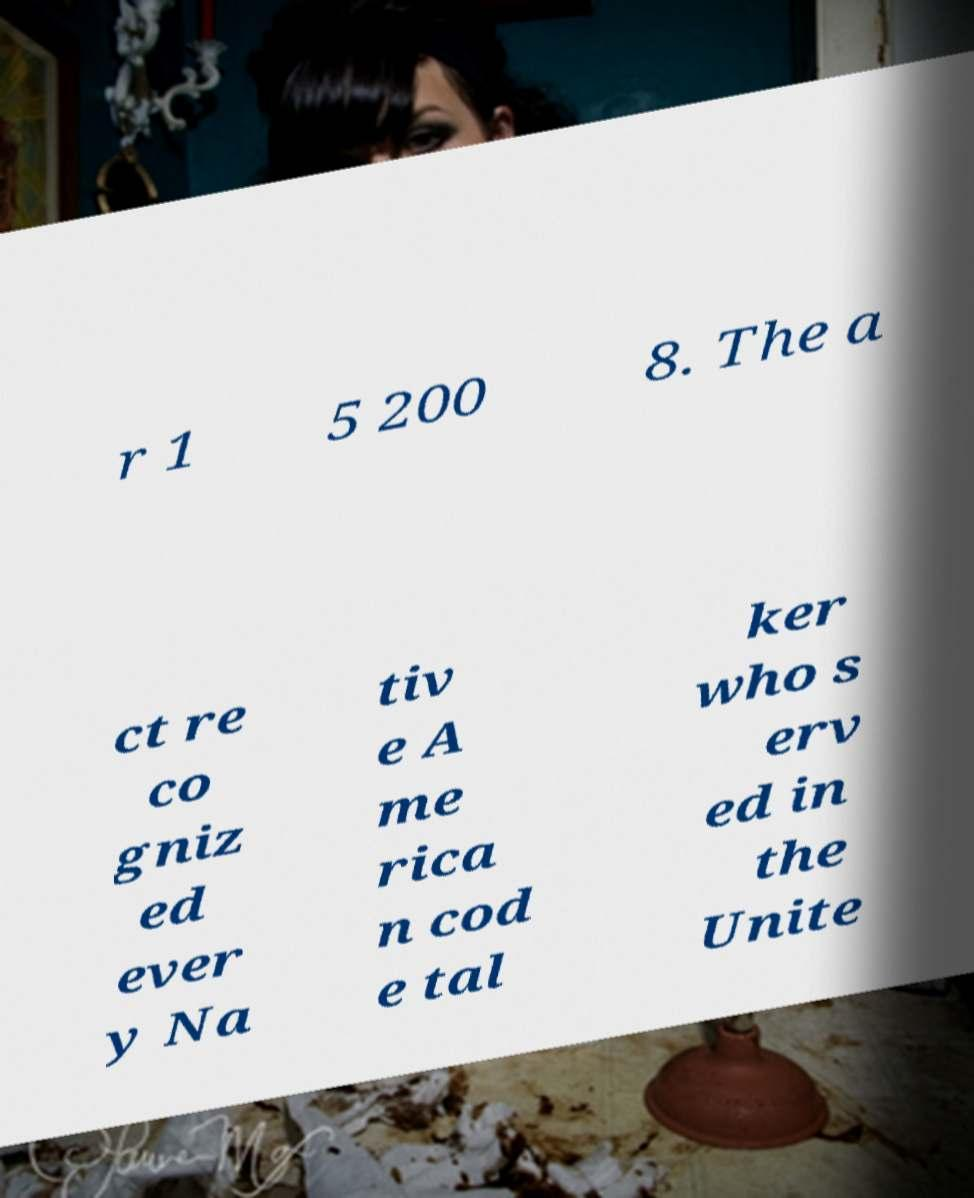For documentation purposes, I need the text within this image transcribed. Could you provide that? r 1 5 200 8. The a ct re co gniz ed ever y Na tiv e A me rica n cod e tal ker who s erv ed in the Unite 